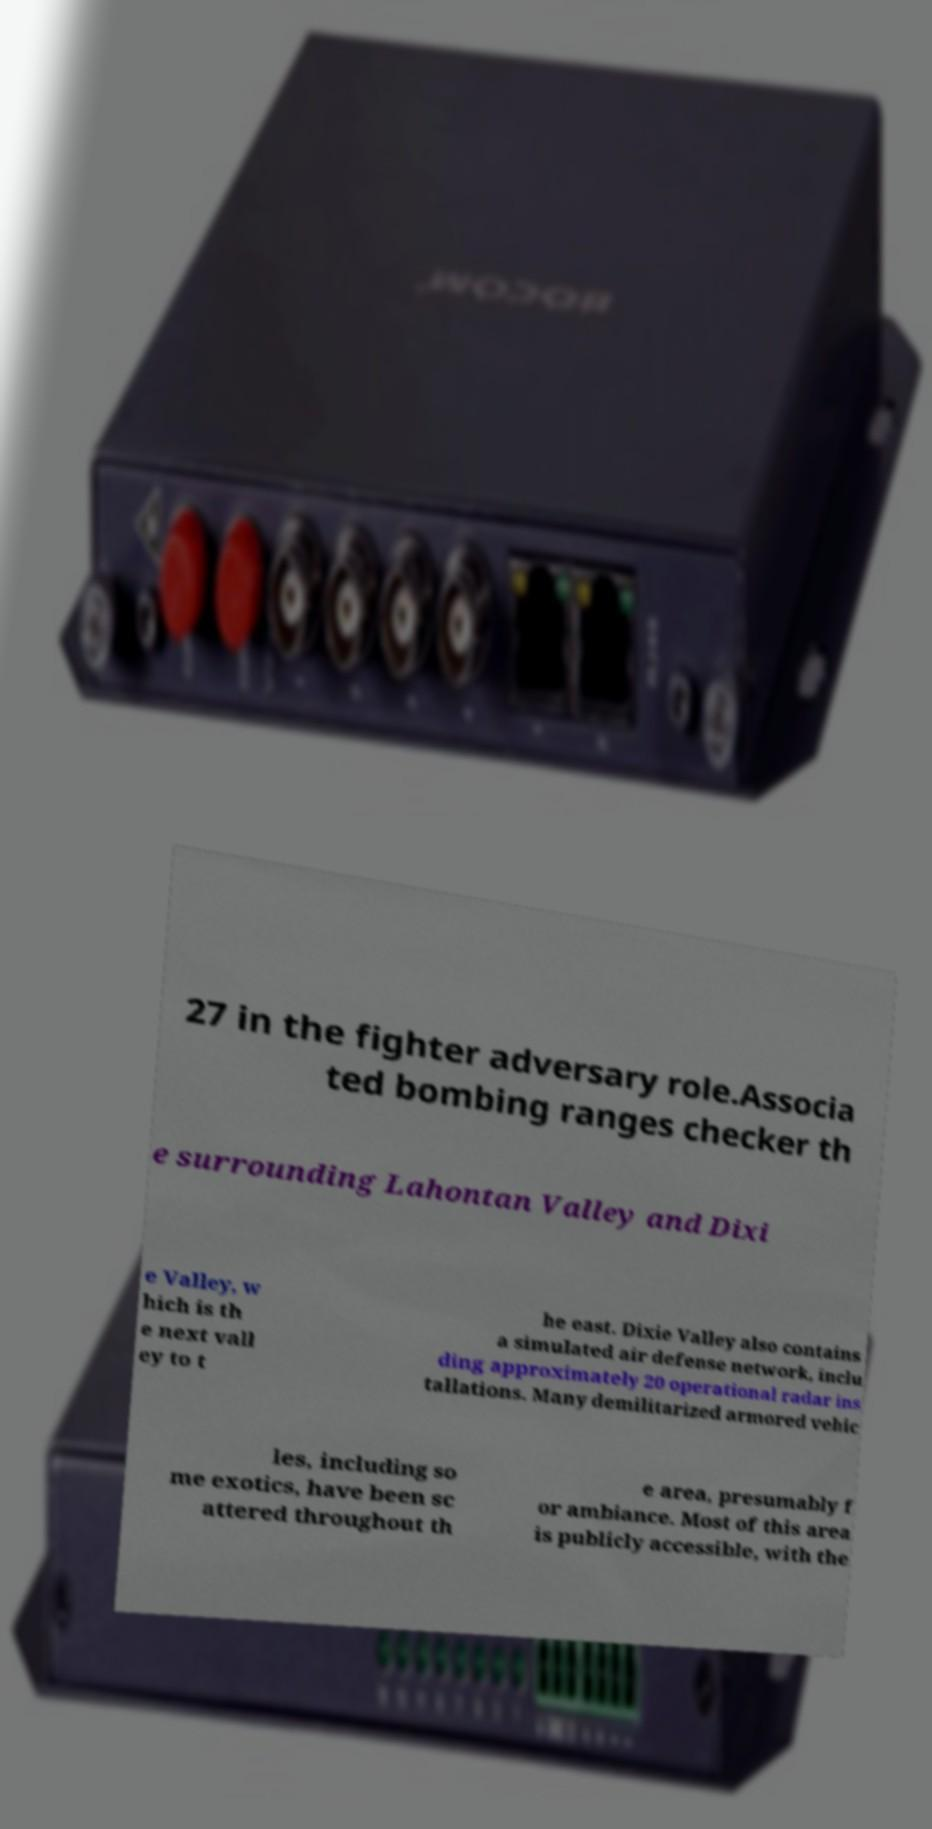Can you accurately transcribe the text from the provided image for me? 27 in the fighter adversary role.Associa ted bombing ranges checker th e surrounding Lahontan Valley and Dixi e Valley, w hich is th e next vall ey to t he east. Dixie Valley also contains a simulated air defense network, inclu ding approximately 20 operational radar ins tallations. Many demilitarized armored vehic les, including so me exotics, have been sc attered throughout th e area, presumably f or ambiance. Most of this area is publicly accessible, with the 